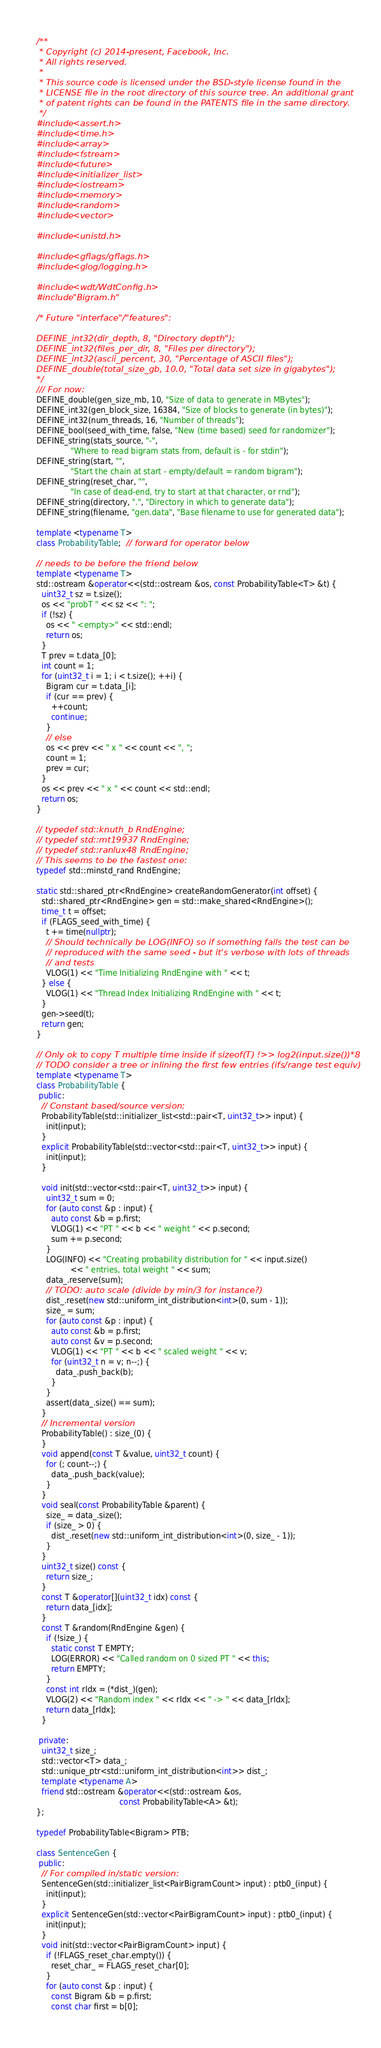Convert code to text. <code><loc_0><loc_0><loc_500><loc_500><_C++_>/**
 * Copyright (c) 2014-present, Facebook, Inc.
 * All rights reserved.
 *
 * This source code is licensed under the BSD-style license found in the
 * LICENSE file in the root directory of this source tree. An additional grant
 * of patent rights can be found in the PATENTS file in the same directory.
 */
#include <assert.h>
#include <time.h>
#include <array>
#include <fstream>
#include <future>
#include <initializer_list>
#include <iostream>
#include <memory>
#include <random>
#include <vector>

#include <unistd.h>

#include <gflags/gflags.h>
#include <glog/logging.h>

#include <wdt/WdtConfig.h>
#include "Bigram.h"

/* Future "interface"/"features":

DEFINE_int32(dir_depth, 8, "Directory depth");
DEFINE_int32(files_per_dir, 8, "Files per directory");
DEFINE_int32(ascii_percent, 30, "Percentage of ASCII files");
DEFINE_double(total_size_gb, 10.0, "Total data set size in gigabytes");
*/
/// For now:
DEFINE_double(gen_size_mb, 10, "Size of data to generate in MBytes");
DEFINE_int32(gen_block_size, 16384, "Size of blocks to generate (in bytes)");
DEFINE_int32(num_threads, 16, "Number of threads");
DEFINE_bool(seed_with_time, false, "New (time based) seed for randomizer");
DEFINE_string(stats_source, "-",
              "Where to read bigram stats from, default is - for stdin");
DEFINE_string(start, "",
              "Start the chain at start - empty/default = random bigram");
DEFINE_string(reset_char, "",
              "In case of dead-end, try to start at that character, or rnd");
DEFINE_string(directory, ".", "Directory in which to generate data");
DEFINE_string(filename, "gen.data", "Base filename to use for generated data");

template <typename T>
class ProbabilityTable;  // forward for operator below

// needs to be before the friend below
template <typename T>
std::ostream &operator<<(std::ostream &os, const ProbabilityTable<T> &t) {
  uint32_t sz = t.size();
  os << "probT " << sz << ": ";
  if (!sz) {
    os << " <empty>" << std::endl;
    return os;
  }
  T prev = t.data_[0];
  int count = 1;
  for (uint32_t i = 1; i < t.size(); ++i) {
    Bigram cur = t.data_[i];
    if (cur == prev) {
      ++count;
      continue;
    }
    // else
    os << prev << " x " << count << ", ";
    count = 1;
    prev = cur;
  }
  os << prev << " x " << count << std::endl;
  return os;
}

// typedef std::knuth_b RndEngine;
// typedef std::mt19937 RndEngine;
// typedef std::ranlux48 RndEngine;
// This seems to be the fastest one:
typedef std::minstd_rand RndEngine;

static std::shared_ptr<RndEngine> createRandomGenerator(int offset) {
  std::shared_ptr<RndEngine> gen = std::make_shared<RndEngine>();
  time_t t = offset;
  if (FLAGS_seed_with_time) {
    t += time(nullptr);
    // Should technically be LOG(INFO) so if something fails the test can be
    // reproduced with the same seed - but it's verbose with lots of threads
    // and tests
    VLOG(1) << "Time Initializing RndEngine with " << t;
  } else {
    VLOG(1) << "Thread Index Initializing RndEngine with " << t;
  }
  gen->seed(t);
  return gen;
}

// Only ok to copy T multiple time inside if sizeof(T) !>> log2(input.size())*8
// TODO consider a tree or inlining the first few entries (ifs/range test equiv)
template <typename T>
class ProbabilityTable {
 public:
  // Constant based/source version:
  ProbabilityTable(std::initializer_list<std::pair<T, uint32_t>> input) {
    init(input);
  }
  explicit ProbabilityTable(std::vector<std::pair<T, uint32_t>> input) {
    init(input);
  }

  void init(std::vector<std::pair<T, uint32_t>> input) {
    uint32_t sum = 0;
    for (auto const &p : input) {
      auto const &b = p.first;
      VLOG(1) << "PT " << b << " weight " << p.second;
      sum += p.second;
    }
    LOG(INFO) << "Creating probability distribution for " << input.size()
              << " entries, total weight " << sum;
    data_.reserve(sum);
    // TODO: auto scale (divide by min/3 for instance?)
    dist_.reset(new std::uniform_int_distribution<int>(0, sum - 1));
    size_ = sum;
    for (auto const &p : input) {
      auto const &b = p.first;
      auto const &v = p.second;
      VLOG(1) << "PT " << b << " scaled weight " << v;
      for (uint32_t n = v; n--;) {
        data_.push_back(b);
      }
    }
    assert(data_.size() == sum);
  }
  // Incremental version
  ProbabilityTable() : size_(0) {
  }
  void append(const T &value, uint32_t count) {
    for (; count--;) {
      data_.push_back(value);
    }
  }
  void seal(const ProbabilityTable &parent) {
    size_ = data_.size();
    if (size_ > 0) {
      dist_.reset(new std::uniform_int_distribution<int>(0, size_ - 1));
    }
  }
  uint32_t size() const {
    return size_;
  }
  const T &operator[](uint32_t idx) const {
    return data_[idx];
  }
  const T &random(RndEngine &gen) {
    if (!size_) {
      static const T EMPTY;
      LOG(ERROR) << "Called random on 0 sized PT " << this;
      return EMPTY;
    }
    const int rIdx = (*dist_)(gen);
    VLOG(2) << "Random index " << rIdx << " -> " << data_[rIdx];
    return data_[rIdx];
  }

 private:
  uint32_t size_;
  std::vector<T> data_;
  std::unique_ptr<std::uniform_int_distribution<int>> dist_;
  template <typename A>
  friend std::ostream &operator<<(std::ostream &os,
                                  const ProbabilityTable<A> &t);
};

typedef ProbabilityTable<Bigram> PTB;

class SentenceGen {
 public:
  // For compiled in/static version:
  SentenceGen(std::initializer_list<PairBigramCount> input) : ptb0_(input) {
    init(input);
  }
  explicit SentenceGen(std::vector<PairBigramCount> input) : ptb0_(input) {
    init(input);
  }
  void init(std::vector<PairBigramCount> input) {
    if (!FLAGS_reset_char.empty()) {
      reset_char_ = FLAGS_reset_char[0];
    }
    for (auto const &p : input) {
      const Bigram &b = p.first;
      const char first = b[0];</code> 